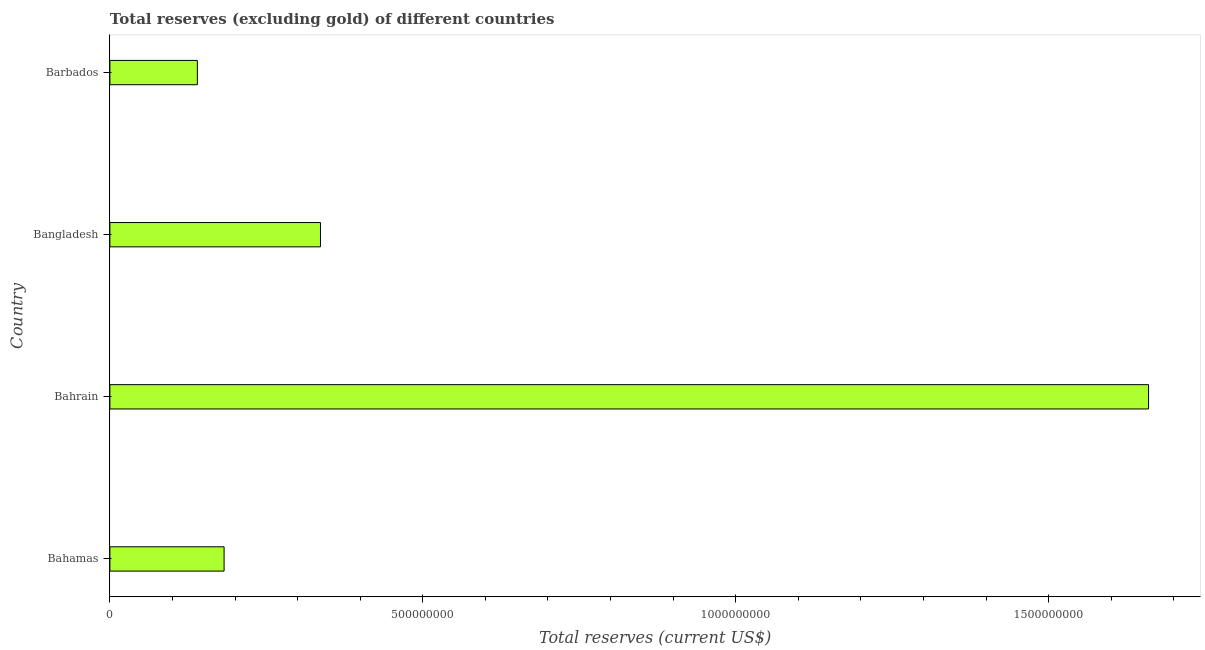Does the graph contain grids?
Give a very brief answer. No. What is the title of the graph?
Offer a terse response. Total reserves (excluding gold) of different countries. What is the label or title of the X-axis?
Offer a very short reply. Total reserves (current US$). What is the label or title of the Y-axis?
Offer a very short reply. Country. What is the total reserves (excluding gold) in Bangladesh?
Keep it short and to the point. 3.37e+08. Across all countries, what is the maximum total reserves (excluding gold)?
Offer a very short reply. 1.66e+09. Across all countries, what is the minimum total reserves (excluding gold)?
Offer a very short reply. 1.40e+08. In which country was the total reserves (excluding gold) maximum?
Keep it short and to the point. Bahrain. In which country was the total reserves (excluding gold) minimum?
Your answer should be very brief. Barbados. What is the sum of the total reserves (excluding gold)?
Keep it short and to the point. 2.32e+09. What is the difference between the total reserves (excluding gold) in Bahrain and Barbados?
Offer a terse response. 1.52e+09. What is the average total reserves (excluding gold) per country?
Make the answer very short. 5.80e+08. What is the median total reserves (excluding gold)?
Ensure brevity in your answer.  2.59e+08. In how many countries, is the total reserves (excluding gold) greater than 1100000000 US$?
Provide a short and direct response. 1. What is the ratio of the total reserves (excluding gold) in Bahamas to that in Barbados?
Offer a very short reply. 1.31. Is the total reserves (excluding gold) in Bahamas less than that in Bangladesh?
Offer a very short reply. Yes. Is the difference between the total reserves (excluding gold) in Bahrain and Bangladesh greater than the difference between any two countries?
Offer a terse response. No. What is the difference between the highest and the second highest total reserves (excluding gold)?
Provide a short and direct response. 1.32e+09. Is the sum of the total reserves (excluding gold) in Bahrain and Barbados greater than the maximum total reserves (excluding gold) across all countries?
Provide a short and direct response. Yes. What is the difference between the highest and the lowest total reserves (excluding gold)?
Give a very brief answer. 1.52e+09. In how many countries, is the total reserves (excluding gold) greater than the average total reserves (excluding gold) taken over all countries?
Your answer should be compact. 1. Are all the bars in the graph horizontal?
Offer a very short reply. Yes. How many countries are there in the graph?
Provide a short and direct response. 4. What is the Total reserves (current US$) of Bahamas?
Your response must be concise. 1.82e+08. What is the Total reserves (current US$) of Bahrain?
Your answer should be compact. 1.66e+09. What is the Total reserves (current US$) of Bangladesh?
Keep it short and to the point. 3.37e+08. What is the Total reserves (current US$) in Barbados?
Your answer should be very brief. 1.40e+08. What is the difference between the Total reserves (current US$) in Bahamas and Bahrain?
Give a very brief answer. -1.48e+09. What is the difference between the Total reserves (current US$) in Bahamas and Bangladesh?
Provide a succinct answer. -1.54e+08. What is the difference between the Total reserves (current US$) in Bahamas and Barbados?
Ensure brevity in your answer.  4.27e+07. What is the difference between the Total reserves (current US$) in Bahrain and Bangladesh?
Offer a terse response. 1.32e+09. What is the difference between the Total reserves (current US$) in Bahrain and Barbados?
Your answer should be very brief. 1.52e+09. What is the difference between the Total reserves (current US$) in Bangladesh and Barbados?
Ensure brevity in your answer.  1.97e+08. What is the ratio of the Total reserves (current US$) in Bahamas to that in Bahrain?
Your answer should be very brief. 0.11. What is the ratio of the Total reserves (current US$) in Bahamas to that in Bangladesh?
Provide a succinct answer. 0.54. What is the ratio of the Total reserves (current US$) in Bahamas to that in Barbados?
Your response must be concise. 1.31. What is the ratio of the Total reserves (current US$) in Bahrain to that in Bangladesh?
Your answer should be very brief. 4.93. What is the ratio of the Total reserves (current US$) in Bahrain to that in Barbados?
Provide a succinct answer. 11.87. What is the ratio of the Total reserves (current US$) in Bangladesh to that in Barbados?
Your answer should be compact. 2.41. 